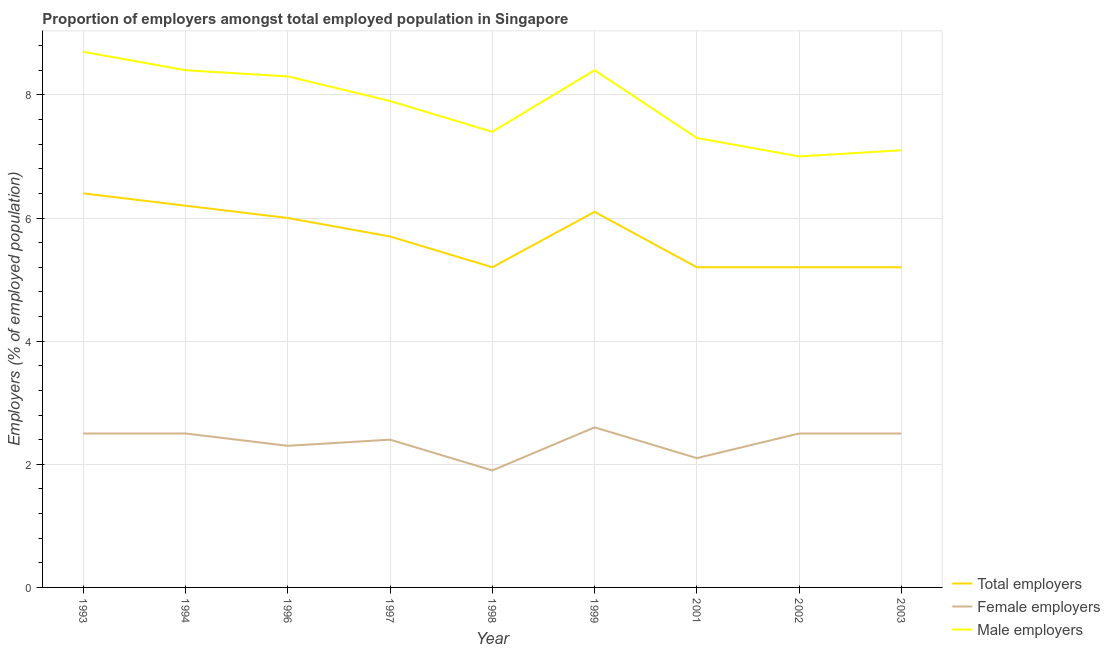How many different coloured lines are there?
Offer a very short reply. 3. Does the line corresponding to percentage of total employers intersect with the line corresponding to percentage of male employers?
Give a very brief answer. No. What is the percentage of female employers in 1998?
Your response must be concise. 1.9. Across all years, what is the maximum percentage of male employers?
Your answer should be compact. 8.7. In which year was the percentage of male employers maximum?
Your answer should be compact. 1993. In which year was the percentage of female employers minimum?
Ensure brevity in your answer.  1998. What is the total percentage of male employers in the graph?
Provide a short and direct response. 70.5. What is the difference between the percentage of female employers in 1993 and that in 2001?
Your answer should be compact. 0.4. What is the difference between the percentage of total employers in 1997 and the percentage of female employers in 1994?
Give a very brief answer. 3.2. What is the average percentage of female employers per year?
Provide a short and direct response. 2.37. In the year 2001, what is the difference between the percentage of total employers and percentage of male employers?
Offer a very short reply. -2.1. What is the ratio of the percentage of total employers in 1997 to that in 2002?
Offer a terse response. 1.1. Is the percentage of male employers in 1994 less than that in 1999?
Ensure brevity in your answer.  No. Is the difference between the percentage of female employers in 1996 and 2001 greater than the difference between the percentage of male employers in 1996 and 2001?
Offer a terse response. No. What is the difference between the highest and the second highest percentage of total employers?
Make the answer very short. 0.2. What is the difference between the highest and the lowest percentage of female employers?
Provide a succinct answer. 0.7. Is the percentage of female employers strictly greater than the percentage of total employers over the years?
Provide a succinct answer. No. How many lines are there?
Keep it short and to the point. 3. How many years are there in the graph?
Your response must be concise. 9. Are the values on the major ticks of Y-axis written in scientific E-notation?
Your answer should be very brief. No. Does the graph contain any zero values?
Offer a terse response. No. Does the graph contain grids?
Give a very brief answer. Yes. How many legend labels are there?
Your answer should be very brief. 3. What is the title of the graph?
Offer a terse response. Proportion of employers amongst total employed population in Singapore. What is the label or title of the Y-axis?
Give a very brief answer. Employers (% of employed population). What is the Employers (% of employed population) of Total employers in 1993?
Provide a short and direct response. 6.4. What is the Employers (% of employed population) in Female employers in 1993?
Offer a very short reply. 2.5. What is the Employers (% of employed population) of Male employers in 1993?
Ensure brevity in your answer.  8.7. What is the Employers (% of employed population) in Total employers in 1994?
Your answer should be compact. 6.2. What is the Employers (% of employed population) of Male employers in 1994?
Keep it short and to the point. 8.4. What is the Employers (% of employed population) in Female employers in 1996?
Provide a succinct answer. 2.3. What is the Employers (% of employed population) of Male employers in 1996?
Give a very brief answer. 8.3. What is the Employers (% of employed population) of Total employers in 1997?
Offer a terse response. 5.7. What is the Employers (% of employed population) of Female employers in 1997?
Your response must be concise. 2.4. What is the Employers (% of employed population) of Male employers in 1997?
Provide a succinct answer. 7.9. What is the Employers (% of employed population) of Total employers in 1998?
Give a very brief answer. 5.2. What is the Employers (% of employed population) in Female employers in 1998?
Make the answer very short. 1.9. What is the Employers (% of employed population) of Male employers in 1998?
Keep it short and to the point. 7.4. What is the Employers (% of employed population) of Total employers in 1999?
Provide a succinct answer. 6.1. What is the Employers (% of employed population) of Female employers in 1999?
Your answer should be compact. 2.6. What is the Employers (% of employed population) of Male employers in 1999?
Give a very brief answer. 8.4. What is the Employers (% of employed population) of Total employers in 2001?
Provide a short and direct response. 5.2. What is the Employers (% of employed population) of Female employers in 2001?
Provide a succinct answer. 2.1. What is the Employers (% of employed population) of Male employers in 2001?
Give a very brief answer. 7.3. What is the Employers (% of employed population) in Total employers in 2002?
Keep it short and to the point. 5.2. What is the Employers (% of employed population) of Female employers in 2002?
Your answer should be very brief. 2.5. What is the Employers (% of employed population) of Total employers in 2003?
Keep it short and to the point. 5.2. What is the Employers (% of employed population) of Female employers in 2003?
Your response must be concise. 2.5. What is the Employers (% of employed population) in Male employers in 2003?
Provide a short and direct response. 7.1. Across all years, what is the maximum Employers (% of employed population) in Total employers?
Ensure brevity in your answer.  6.4. Across all years, what is the maximum Employers (% of employed population) of Female employers?
Provide a succinct answer. 2.6. Across all years, what is the maximum Employers (% of employed population) of Male employers?
Your answer should be very brief. 8.7. Across all years, what is the minimum Employers (% of employed population) of Total employers?
Provide a short and direct response. 5.2. Across all years, what is the minimum Employers (% of employed population) in Female employers?
Make the answer very short. 1.9. Across all years, what is the minimum Employers (% of employed population) of Male employers?
Offer a very short reply. 7. What is the total Employers (% of employed population) of Total employers in the graph?
Offer a very short reply. 51.2. What is the total Employers (% of employed population) in Female employers in the graph?
Make the answer very short. 21.3. What is the total Employers (% of employed population) in Male employers in the graph?
Give a very brief answer. 70.5. What is the difference between the Employers (% of employed population) in Total employers in 1993 and that in 1994?
Provide a short and direct response. 0.2. What is the difference between the Employers (% of employed population) of Male employers in 1993 and that in 1994?
Provide a short and direct response. 0.3. What is the difference between the Employers (% of employed population) of Total employers in 1993 and that in 1996?
Provide a short and direct response. 0.4. What is the difference between the Employers (% of employed population) of Female employers in 1993 and that in 1996?
Your response must be concise. 0.2. What is the difference between the Employers (% of employed population) in Female employers in 1993 and that in 1997?
Your response must be concise. 0.1. What is the difference between the Employers (% of employed population) of Male employers in 1993 and that in 1998?
Offer a very short reply. 1.3. What is the difference between the Employers (% of employed population) of Male employers in 1993 and that in 2002?
Offer a very short reply. 1.7. What is the difference between the Employers (% of employed population) of Total employers in 1993 and that in 2003?
Your answer should be compact. 1.2. What is the difference between the Employers (% of employed population) in Female employers in 1993 and that in 2003?
Ensure brevity in your answer.  0. What is the difference between the Employers (% of employed population) in Male employers in 1993 and that in 2003?
Your answer should be compact. 1.6. What is the difference between the Employers (% of employed population) in Total employers in 1994 and that in 1996?
Your response must be concise. 0.2. What is the difference between the Employers (% of employed population) of Male employers in 1994 and that in 1996?
Provide a succinct answer. 0.1. What is the difference between the Employers (% of employed population) of Male employers in 1994 and that in 1997?
Your answer should be compact. 0.5. What is the difference between the Employers (% of employed population) of Total employers in 1994 and that in 1998?
Provide a succinct answer. 1. What is the difference between the Employers (% of employed population) in Female employers in 1994 and that in 1998?
Provide a short and direct response. 0.6. What is the difference between the Employers (% of employed population) in Total employers in 1994 and that in 1999?
Offer a very short reply. 0.1. What is the difference between the Employers (% of employed population) of Female employers in 1994 and that in 1999?
Your response must be concise. -0.1. What is the difference between the Employers (% of employed population) of Total employers in 1994 and that in 2001?
Ensure brevity in your answer.  1. What is the difference between the Employers (% of employed population) in Female employers in 1994 and that in 2001?
Your answer should be compact. 0.4. What is the difference between the Employers (% of employed population) of Male employers in 1994 and that in 2001?
Your response must be concise. 1.1. What is the difference between the Employers (% of employed population) of Female employers in 1994 and that in 2002?
Ensure brevity in your answer.  0. What is the difference between the Employers (% of employed population) in Female employers in 1994 and that in 2003?
Offer a very short reply. 0. What is the difference between the Employers (% of employed population) in Male employers in 1994 and that in 2003?
Offer a terse response. 1.3. What is the difference between the Employers (% of employed population) of Total employers in 1996 and that in 1997?
Give a very brief answer. 0.3. What is the difference between the Employers (% of employed population) in Male employers in 1996 and that in 1997?
Offer a terse response. 0.4. What is the difference between the Employers (% of employed population) of Female employers in 1996 and that in 1998?
Offer a terse response. 0.4. What is the difference between the Employers (% of employed population) in Male employers in 1996 and that in 1998?
Offer a terse response. 0.9. What is the difference between the Employers (% of employed population) of Total employers in 1996 and that in 1999?
Your response must be concise. -0.1. What is the difference between the Employers (% of employed population) of Female employers in 1996 and that in 1999?
Your answer should be very brief. -0.3. What is the difference between the Employers (% of employed population) of Male employers in 1996 and that in 1999?
Make the answer very short. -0.1. What is the difference between the Employers (% of employed population) of Female employers in 1996 and that in 2001?
Make the answer very short. 0.2. What is the difference between the Employers (% of employed population) of Male employers in 1996 and that in 2001?
Offer a very short reply. 1. What is the difference between the Employers (% of employed population) of Male employers in 1996 and that in 2002?
Offer a terse response. 1.3. What is the difference between the Employers (% of employed population) of Female employers in 1996 and that in 2003?
Ensure brevity in your answer.  -0.2. What is the difference between the Employers (% of employed population) of Total employers in 1997 and that in 1998?
Offer a terse response. 0.5. What is the difference between the Employers (% of employed population) of Male employers in 1997 and that in 1998?
Give a very brief answer. 0.5. What is the difference between the Employers (% of employed population) of Male employers in 1997 and that in 2001?
Provide a succinct answer. 0.6. What is the difference between the Employers (% of employed population) of Female employers in 1997 and that in 2002?
Provide a short and direct response. -0.1. What is the difference between the Employers (% of employed population) in Total employers in 1997 and that in 2003?
Your answer should be compact. 0.5. What is the difference between the Employers (% of employed population) of Female employers in 1997 and that in 2003?
Ensure brevity in your answer.  -0.1. What is the difference between the Employers (% of employed population) in Total employers in 1998 and that in 1999?
Give a very brief answer. -0.9. What is the difference between the Employers (% of employed population) in Female employers in 1998 and that in 1999?
Give a very brief answer. -0.7. What is the difference between the Employers (% of employed population) of Total employers in 1998 and that in 2001?
Provide a succinct answer. 0. What is the difference between the Employers (% of employed population) in Female employers in 1998 and that in 2001?
Offer a terse response. -0.2. What is the difference between the Employers (% of employed population) in Male employers in 1998 and that in 2001?
Your answer should be compact. 0.1. What is the difference between the Employers (% of employed population) in Total employers in 1998 and that in 2002?
Provide a short and direct response. 0. What is the difference between the Employers (% of employed population) in Male employers in 1998 and that in 2002?
Provide a short and direct response. 0.4. What is the difference between the Employers (% of employed population) in Total employers in 1998 and that in 2003?
Offer a terse response. 0. What is the difference between the Employers (% of employed population) of Total employers in 1999 and that in 2001?
Your response must be concise. 0.9. What is the difference between the Employers (% of employed population) in Male employers in 1999 and that in 2001?
Offer a terse response. 1.1. What is the difference between the Employers (% of employed population) of Total employers in 1999 and that in 2003?
Your response must be concise. 0.9. What is the difference between the Employers (% of employed population) in Total employers in 2001 and that in 2002?
Provide a succinct answer. 0. What is the difference between the Employers (% of employed population) in Male employers in 2001 and that in 2002?
Offer a very short reply. 0.3. What is the difference between the Employers (% of employed population) in Total employers in 2001 and that in 2003?
Your response must be concise. 0. What is the difference between the Employers (% of employed population) in Female employers in 2001 and that in 2003?
Provide a succinct answer. -0.4. What is the difference between the Employers (% of employed population) of Total employers in 2002 and that in 2003?
Make the answer very short. 0. What is the difference between the Employers (% of employed population) of Female employers in 2002 and that in 2003?
Offer a very short reply. 0. What is the difference between the Employers (% of employed population) in Male employers in 2002 and that in 2003?
Offer a terse response. -0.1. What is the difference between the Employers (% of employed population) of Total employers in 1993 and the Employers (% of employed population) of Female employers in 1994?
Give a very brief answer. 3.9. What is the difference between the Employers (% of employed population) of Total employers in 1993 and the Employers (% of employed population) of Male employers in 1994?
Your response must be concise. -2. What is the difference between the Employers (% of employed population) of Female employers in 1993 and the Employers (% of employed population) of Male employers in 1994?
Offer a terse response. -5.9. What is the difference between the Employers (% of employed population) of Total employers in 1993 and the Employers (% of employed population) of Female employers in 1996?
Your response must be concise. 4.1. What is the difference between the Employers (% of employed population) in Total employers in 1993 and the Employers (% of employed population) in Male employers in 1996?
Your answer should be very brief. -1.9. What is the difference between the Employers (% of employed population) in Total employers in 1993 and the Employers (% of employed population) in Female employers in 1997?
Keep it short and to the point. 4. What is the difference between the Employers (% of employed population) in Total employers in 1993 and the Employers (% of employed population) in Male employers in 1997?
Ensure brevity in your answer.  -1.5. What is the difference between the Employers (% of employed population) of Female employers in 1993 and the Employers (% of employed population) of Male employers in 1997?
Provide a succinct answer. -5.4. What is the difference between the Employers (% of employed population) in Female employers in 1993 and the Employers (% of employed population) in Male employers in 1998?
Keep it short and to the point. -4.9. What is the difference between the Employers (% of employed population) of Total employers in 1993 and the Employers (% of employed population) of Female employers in 1999?
Offer a very short reply. 3.8. What is the difference between the Employers (% of employed population) in Female employers in 1993 and the Employers (% of employed population) in Male employers in 1999?
Make the answer very short. -5.9. What is the difference between the Employers (% of employed population) of Total employers in 1993 and the Employers (% of employed population) of Male employers in 2001?
Your answer should be very brief. -0.9. What is the difference between the Employers (% of employed population) of Female employers in 1993 and the Employers (% of employed population) of Male employers in 2001?
Offer a very short reply. -4.8. What is the difference between the Employers (% of employed population) of Total employers in 1993 and the Employers (% of employed population) of Female employers in 2003?
Offer a terse response. 3.9. What is the difference between the Employers (% of employed population) in Total employers in 1993 and the Employers (% of employed population) in Male employers in 2003?
Your answer should be very brief. -0.7. What is the difference between the Employers (% of employed population) of Female employers in 1994 and the Employers (% of employed population) of Male employers in 1997?
Offer a very short reply. -5.4. What is the difference between the Employers (% of employed population) in Female employers in 1994 and the Employers (% of employed population) in Male employers in 1998?
Keep it short and to the point. -4.9. What is the difference between the Employers (% of employed population) of Total employers in 1994 and the Employers (% of employed population) of Female employers in 1999?
Offer a terse response. 3.6. What is the difference between the Employers (% of employed population) of Total employers in 1994 and the Employers (% of employed population) of Female employers in 2001?
Keep it short and to the point. 4.1. What is the difference between the Employers (% of employed population) of Total employers in 1994 and the Employers (% of employed population) of Male employers in 2001?
Provide a short and direct response. -1.1. What is the difference between the Employers (% of employed population) of Female employers in 1994 and the Employers (% of employed population) of Male employers in 2003?
Your answer should be very brief. -4.6. What is the difference between the Employers (% of employed population) of Total employers in 1996 and the Employers (% of employed population) of Female employers in 1997?
Give a very brief answer. 3.6. What is the difference between the Employers (% of employed population) in Total employers in 1996 and the Employers (% of employed population) in Female employers in 1998?
Keep it short and to the point. 4.1. What is the difference between the Employers (% of employed population) of Female employers in 1996 and the Employers (% of employed population) of Male employers in 1998?
Your answer should be compact. -5.1. What is the difference between the Employers (% of employed population) in Total employers in 1996 and the Employers (% of employed population) in Male employers in 1999?
Provide a short and direct response. -2.4. What is the difference between the Employers (% of employed population) in Total employers in 1996 and the Employers (% of employed population) in Male employers in 2001?
Make the answer very short. -1.3. What is the difference between the Employers (% of employed population) of Total employers in 1996 and the Employers (% of employed population) of Female employers in 2002?
Offer a terse response. 3.5. What is the difference between the Employers (% of employed population) of Female employers in 1996 and the Employers (% of employed population) of Male employers in 2002?
Provide a short and direct response. -4.7. What is the difference between the Employers (% of employed population) in Female employers in 1996 and the Employers (% of employed population) in Male employers in 2003?
Provide a succinct answer. -4.8. What is the difference between the Employers (% of employed population) in Female employers in 1997 and the Employers (% of employed population) in Male employers in 1998?
Your answer should be very brief. -5. What is the difference between the Employers (% of employed population) in Female employers in 1997 and the Employers (% of employed population) in Male employers in 1999?
Your answer should be compact. -6. What is the difference between the Employers (% of employed population) in Total employers in 1997 and the Employers (% of employed population) in Male employers in 2001?
Give a very brief answer. -1.6. What is the difference between the Employers (% of employed population) in Female employers in 1997 and the Employers (% of employed population) in Male employers in 2001?
Make the answer very short. -4.9. What is the difference between the Employers (% of employed population) of Total employers in 1997 and the Employers (% of employed population) of Female employers in 2002?
Ensure brevity in your answer.  3.2. What is the difference between the Employers (% of employed population) of Female employers in 1997 and the Employers (% of employed population) of Male employers in 2002?
Your answer should be compact. -4.6. What is the difference between the Employers (% of employed population) in Total employers in 1997 and the Employers (% of employed population) in Female employers in 2003?
Provide a succinct answer. 3.2. What is the difference between the Employers (% of employed population) of Female employers in 1998 and the Employers (% of employed population) of Male employers in 1999?
Keep it short and to the point. -6.5. What is the difference between the Employers (% of employed population) in Female employers in 1998 and the Employers (% of employed population) in Male employers in 2001?
Offer a very short reply. -5.4. What is the difference between the Employers (% of employed population) of Total employers in 1998 and the Employers (% of employed population) of Female employers in 2002?
Your answer should be compact. 2.7. What is the difference between the Employers (% of employed population) of Total employers in 1998 and the Employers (% of employed population) of Male employers in 2002?
Offer a terse response. -1.8. What is the difference between the Employers (% of employed population) of Female employers in 1998 and the Employers (% of employed population) of Male employers in 2003?
Offer a terse response. -5.2. What is the difference between the Employers (% of employed population) in Female employers in 1999 and the Employers (% of employed population) in Male employers in 2001?
Make the answer very short. -4.7. What is the difference between the Employers (% of employed population) in Total employers in 1999 and the Employers (% of employed population) in Male employers in 2002?
Offer a very short reply. -0.9. What is the difference between the Employers (% of employed population) in Total employers in 1999 and the Employers (% of employed population) in Female employers in 2003?
Your answer should be very brief. 3.6. What is the difference between the Employers (% of employed population) of Total employers in 2001 and the Employers (% of employed population) of Male employers in 2002?
Your answer should be very brief. -1.8. What is the difference between the Employers (% of employed population) in Total employers in 2002 and the Employers (% of employed population) in Female employers in 2003?
Provide a short and direct response. 2.7. What is the average Employers (% of employed population) in Total employers per year?
Your answer should be compact. 5.69. What is the average Employers (% of employed population) of Female employers per year?
Your response must be concise. 2.37. What is the average Employers (% of employed population) of Male employers per year?
Ensure brevity in your answer.  7.83. In the year 1993, what is the difference between the Employers (% of employed population) in Total employers and Employers (% of employed population) in Male employers?
Offer a terse response. -2.3. In the year 1994, what is the difference between the Employers (% of employed population) of Total employers and Employers (% of employed population) of Female employers?
Your response must be concise. 3.7. In the year 1996, what is the difference between the Employers (% of employed population) of Total employers and Employers (% of employed population) of Female employers?
Your response must be concise. 3.7. In the year 1996, what is the difference between the Employers (% of employed population) of Female employers and Employers (% of employed population) of Male employers?
Give a very brief answer. -6. In the year 1997, what is the difference between the Employers (% of employed population) in Total employers and Employers (% of employed population) in Female employers?
Ensure brevity in your answer.  3.3. In the year 1997, what is the difference between the Employers (% of employed population) in Total employers and Employers (% of employed population) in Male employers?
Offer a terse response. -2.2. In the year 1999, what is the difference between the Employers (% of employed population) in Female employers and Employers (% of employed population) in Male employers?
Provide a succinct answer. -5.8. In the year 2001, what is the difference between the Employers (% of employed population) of Total employers and Employers (% of employed population) of Male employers?
Your answer should be very brief. -2.1. In the year 2002, what is the difference between the Employers (% of employed population) of Total employers and Employers (% of employed population) of Male employers?
Give a very brief answer. -1.8. In the year 2002, what is the difference between the Employers (% of employed population) in Female employers and Employers (% of employed population) in Male employers?
Provide a succinct answer. -4.5. In the year 2003, what is the difference between the Employers (% of employed population) in Total employers and Employers (% of employed population) in Female employers?
Keep it short and to the point. 2.7. In the year 2003, what is the difference between the Employers (% of employed population) of Female employers and Employers (% of employed population) of Male employers?
Offer a very short reply. -4.6. What is the ratio of the Employers (% of employed population) in Total employers in 1993 to that in 1994?
Your answer should be compact. 1.03. What is the ratio of the Employers (% of employed population) in Female employers in 1993 to that in 1994?
Offer a very short reply. 1. What is the ratio of the Employers (% of employed population) of Male employers in 1993 to that in 1994?
Provide a short and direct response. 1.04. What is the ratio of the Employers (% of employed population) of Total employers in 1993 to that in 1996?
Offer a very short reply. 1.07. What is the ratio of the Employers (% of employed population) of Female employers in 1993 to that in 1996?
Offer a terse response. 1.09. What is the ratio of the Employers (% of employed population) of Male employers in 1993 to that in 1996?
Provide a succinct answer. 1.05. What is the ratio of the Employers (% of employed population) of Total employers in 1993 to that in 1997?
Your answer should be very brief. 1.12. What is the ratio of the Employers (% of employed population) of Female employers in 1993 to that in 1997?
Ensure brevity in your answer.  1.04. What is the ratio of the Employers (% of employed population) of Male employers in 1993 to that in 1997?
Provide a succinct answer. 1.1. What is the ratio of the Employers (% of employed population) of Total employers in 1993 to that in 1998?
Ensure brevity in your answer.  1.23. What is the ratio of the Employers (% of employed population) in Female employers in 1993 to that in 1998?
Your answer should be very brief. 1.32. What is the ratio of the Employers (% of employed population) of Male employers in 1993 to that in 1998?
Give a very brief answer. 1.18. What is the ratio of the Employers (% of employed population) of Total employers in 1993 to that in 1999?
Give a very brief answer. 1.05. What is the ratio of the Employers (% of employed population) in Female employers in 1993 to that in 1999?
Make the answer very short. 0.96. What is the ratio of the Employers (% of employed population) in Male employers in 1993 to that in 1999?
Provide a succinct answer. 1.04. What is the ratio of the Employers (% of employed population) of Total employers in 1993 to that in 2001?
Ensure brevity in your answer.  1.23. What is the ratio of the Employers (% of employed population) in Female employers in 1993 to that in 2001?
Keep it short and to the point. 1.19. What is the ratio of the Employers (% of employed population) of Male employers in 1993 to that in 2001?
Provide a short and direct response. 1.19. What is the ratio of the Employers (% of employed population) of Total employers in 1993 to that in 2002?
Offer a terse response. 1.23. What is the ratio of the Employers (% of employed population) in Female employers in 1993 to that in 2002?
Ensure brevity in your answer.  1. What is the ratio of the Employers (% of employed population) of Male employers in 1993 to that in 2002?
Make the answer very short. 1.24. What is the ratio of the Employers (% of employed population) in Total employers in 1993 to that in 2003?
Your answer should be compact. 1.23. What is the ratio of the Employers (% of employed population) in Female employers in 1993 to that in 2003?
Provide a succinct answer. 1. What is the ratio of the Employers (% of employed population) in Male employers in 1993 to that in 2003?
Offer a terse response. 1.23. What is the ratio of the Employers (% of employed population) in Total employers in 1994 to that in 1996?
Give a very brief answer. 1.03. What is the ratio of the Employers (% of employed population) of Female employers in 1994 to that in 1996?
Give a very brief answer. 1.09. What is the ratio of the Employers (% of employed population) of Total employers in 1994 to that in 1997?
Provide a succinct answer. 1.09. What is the ratio of the Employers (% of employed population) in Female employers in 1994 to that in 1997?
Make the answer very short. 1.04. What is the ratio of the Employers (% of employed population) in Male employers in 1994 to that in 1997?
Keep it short and to the point. 1.06. What is the ratio of the Employers (% of employed population) in Total employers in 1994 to that in 1998?
Provide a short and direct response. 1.19. What is the ratio of the Employers (% of employed population) of Female employers in 1994 to that in 1998?
Your answer should be compact. 1.32. What is the ratio of the Employers (% of employed population) of Male employers in 1994 to that in 1998?
Provide a short and direct response. 1.14. What is the ratio of the Employers (% of employed population) of Total employers in 1994 to that in 1999?
Ensure brevity in your answer.  1.02. What is the ratio of the Employers (% of employed population) of Female employers in 1994 to that in 1999?
Ensure brevity in your answer.  0.96. What is the ratio of the Employers (% of employed population) of Total employers in 1994 to that in 2001?
Make the answer very short. 1.19. What is the ratio of the Employers (% of employed population) of Female employers in 1994 to that in 2001?
Your answer should be very brief. 1.19. What is the ratio of the Employers (% of employed population) in Male employers in 1994 to that in 2001?
Your answer should be very brief. 1.15. What is the ratio of the Employers (% of employed population) of Total employers in 1994 to that in 2002?
Your response must be concise. 1.19. What is the ratio of the Employers (% of employed population) in Male employers in 1994 to that in 2002?
Offer a terse response. 1.2. What is the ratio of the Employers (% of employed population) in Total employers in 1994 to that in 2003?
Your answer should be compact. 1.19. What is the ratio of the Employers (% of employed population) of Male employers in 1994 to that in 2003?
Keep it short and to the point. 1.18. What is the ratio of the Employers (% of employed population) of Total employers in 1996 to that in 1997?
Make the answer very short. 1.05. What is the ratio of the Employers (% of employed population) of Male employers in 1996 to that in 1997?
Provide a succinct answer. 1.05. What is the ratio of the Employers (% of employed population) of Total employers in 1996 to that in 1998?
Give a very brief answer. 1.15. What is the ratio of the Employers (% of employed population) in Female employers in 1996 to that in 1998?
Offer a terse response. 1.21. What is the ratio of the Employers (% of employed population) in Male employers in 1996 to that in 1998?
Offer a very short reply. 1.12. What is the ratio of the Employers (% of employed population) in Total employers in 1996 to that in 1999?
Give a very brief answer. 0.98. What is the ratio of the Employers (% of employed population) of Female employers in 1996 to that in 1999?
Give a very brief answer. 0.88. What is the ratio of the Employers (% of employed population) in Total employers in 1996 to that in 2001?
Ensure brevity in your answer.  1.15. What is the ratio of the Employers (% of employed population) in Female employers in 1996 to that in 2001?
Give a very brief answer. 1.1. What is the ratio of the Employers (% of employed population) in Male employers in 1996 to that in 2001?
Give a very brief answer. 1.14. What is the ratio of the Employers (% of employed population) in Total employers in 1996 to that in 2002?
Your response must be concise. 1.15. What is the ratio of the Employers (% of employed population) in Female employers in 1996 to that in 2002?
Your answer should be compact. 0.92. What is the ratio of the Employers (% of employed population) of Male employers in 1996 to that in 2002?
Ensure brevity in your answer.  1.19. What is the ratio of the Employers (% of employed population) of Total employers in 1996 to that in 2003?
Keep it short and to the point. 1.15. What is the ratio of the Employers (% of employed population) in Male employers in 1996 to that in 2003?
Provide a short and direct response. 1.17. What is the ratio of the Employers (% of employed population) of Total employers in 1997 to that in 1998?
Keep it short and to the point. 1.1. What is the ratio of the Employers (% of employed population) in Female employers in 1997 to that in 1998?
Keep it short and to the point. 1.26. What is the ratio of the Employers (% of employed population) in Male employers in 1997 to that in 1998?
Provide a short and direct response. 1.07. What is the ratio of the Employers (% of employed population) in Total employers in 1997 to that in 1999?
Make the answer very short. 0.93. What is the ratio of the Employers (% of employed population) in Female employers in 1997 to that in 1999?
Your response must be concise. 0.92. What is the ratio of the Employers (% of employed population) in Male employers in 1997 to that in 1999?
Your response must be concise. 0.94. What is the ratio of the Employers (% of employed population) in Total employers in 1997 to that in 2001?
Provide a short and direct response. 1.1. What is the ratio of the Employers (% of employed population) of Male employers in 1997 to that in 2001?
Your answer should be very brief. 1.08. What is the ratio of the Employers (% of employed population) in Total employers in 1997 to that in 2002?
Give a very brief answer. 1.1. What is the ratio of the Employers (% of employed population) in Female employers in 1997 to that in 2002?
Provide a short and direct response. 0.96. What is the ratio of the Employers (% of employed population) of Male employers in 1997 to that in 2002?
Provide a short and direct response. 1.13. What is the ratio of the Employers (% of employed population) of Total employers in 1997 to that in 2003?
Offer a very short reply. 1.1. What is the ratio of the Employers (% of employed population) of Male employers in 1997 to that in 2003?
Keep it short and to the point. 1.11. What is the ratio of the Employers (% of employed population) of Total employers in 1998 to that in 1999?
Give a very brief answer. 0.85. What is the ratio of the Employers (% of employed population) of Female employers in 1998 to that in 1999?
Your answer should be compact. 0.73. What is the ratio of the Employers (% of employed population) of Male employers in 1998 to that in 1999?
Your response must be concise. 0.88. What is the ratio of the Employers (% of employed population) of Female employers in 1998 to that in 2001?
Make the answer very short. 0.9. What is the ratio of the Employers (% of employed population) of Male employers in 1998 to that in 2001?
Offer a terse response. 1.01. What is the ratio of the Employers (% of employed population) in Female employers in 1998 to that in 2002?
Ensure brevity in your answer.  0.76. What is the ratio of the Employers (% of employed population) in Male employers in 1998 to that in 2002?
Your answer should be very brief. 1.06. What is the ratio of the Employers (% of employed population) of Female employers in 1998 to that in 2003?
Your answer should be very brief. 0.76. What is the ratio of the Employers (% of employed population) of Male employers in 1998 to that in 2003?
Offer a very short reply. 1.04. What is the ratio of the Employers (% of employed population) in Total employers in 1999 to that in 2001?
Your answer should be very brief. 1.17. What is the ratio of the Employers (% of employed population) in Female employers in 1999 to that in 2001?
Make the answer very short. 1.24. What is the ratio of the Employers (% of employed population) in Male employers in 1999 to that in 2001?
Make the answer very short. 1.15. What is the ratio of the Employers (% of employed population) in Total employers in 1999 to that in 2002?
Provide a short and direct response. 1.17. What is the ratio of the Employers (% of employed population) in Total employers in 1999 to that in 2003?
Make the answer very short. 1.17. What is the ratio of the Employers (% of employed population) of Male employers in 1999 to that in 2003?
Give a very brief answer. 1.18. What is the ratio of the Employers (% of employed population) in Total employers in 2001 to that in 2002?
Ensure brevity in your answer.  1. What is the ratio of the Employers (% of employed population) in Female employers in 2001 to that in 2002?
Offer a terse response. 0.84. What is the ratio of the Employers (% of employed population) in Male employers in 2001 to that in 2002?
Offer a very short reply. 1.04. What is the ratio of the Employers (% of employed population) in Female employers in 2001 to that in 2003?
Your response must be concise. 0.84. What is the ratio of the Employers (% of employed population) in Male employers in 2001 to that in 2003?
Give a very brief answer. 1.03. What is the ratio of the Employers (% of employed population) in Total employers in 2002 to that in 2003?
Your answer should be compact. 1. What is the ratio of the Employers (% of employed population) in Male employers in 2002 to that in 2003?
Provide a short and direct response. 0.99. What is the difference between the highest and the lowest Employers (% of employed population) of Total employers?
Your answer should be very brief. 1.2. What is the difference between the highest and the lowest Employers (% of employed population) of Male employers?
Give a very brief answer. 1.7. 